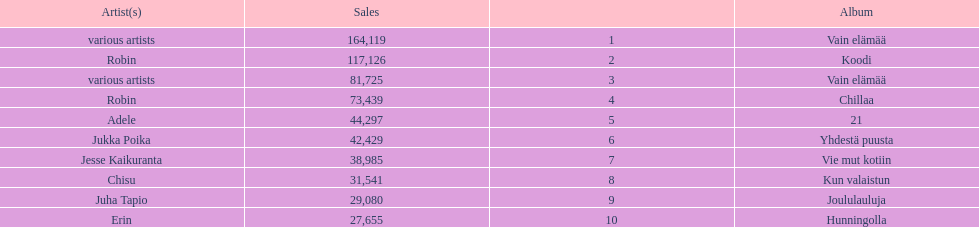Which album has the highest number of sales but doesn't have a designated artist? Vain elämää. 